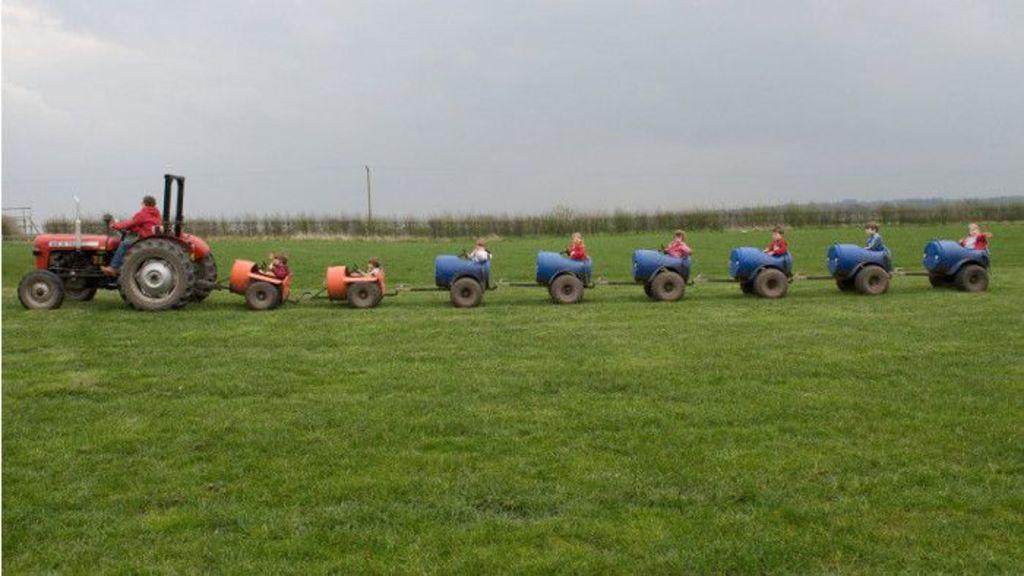What is the main subject of the image? The main subject of the image is a tractor. What are the people in the image doing? The people are seated on the back of the tractor. What are the people sitting on? The people are sitting on drums. What type of terrain is visible in the image? There is grass on the ground in the image. What else can be seen in the image besides the tractor and people? There are plants visible in the image, as well as an electric pole. How would you describe the weather in the image? The sky is cloudy in the image. What type of list can be seen hanging from the electric pole in the image? There is no list hanging from the electric pole in the image. Can you tell me how many times the people on the tractor are kicking a cloth in the image? There is no cloth or kicking activity present in the image. 